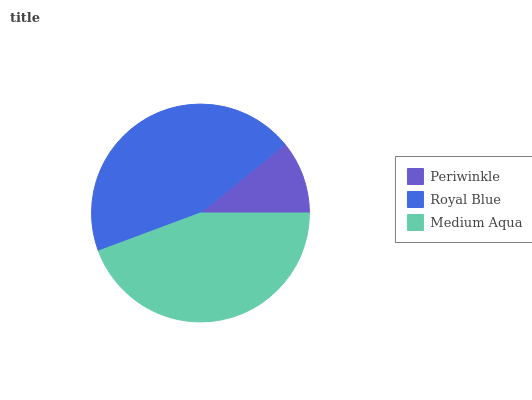Is Periwinkle the minimum?
Answer yes or no. Yes. Is Royal Blue the maximum?
Answer yes or no. Yes. Is Medium Aqua the minimum?
Answer yes or no. No. Is Medium Aqua the maximum?
Answer yes or no. No. Is Royal Blue greater than Medium Aqua?
Answer yes or no. Yes. Is Medium Aqua less than Royal Blue?
Answer yes or no. Yes. Is Medium Aqua greater than Royal Blue?
Answer yes or no. No. Is Royal Blue less than Medium Aqua?
Answer yes or no. No. Is Medium Aqua the high median?
Answer yes or no. Yes. Is Medium Aqua the low median?
Answer yes or no. Yes. Is Periwinkle the high median?
Answer yes or no. No. Is Periwinkle the low median?
Answer yes or no. No. 